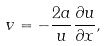<formula> <loc_0><loc_0><loc_500><loc_500>v = - \frac { 2 a } { u } \frac { \partial u } { \partial x } ,</formula> 